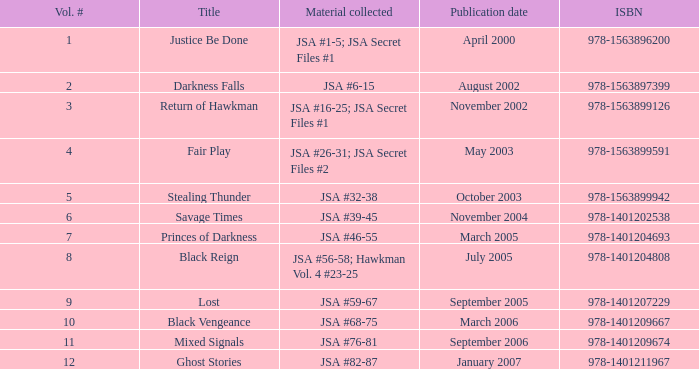What's the Lowest Volume Number that was published November 2004? 6.0. 